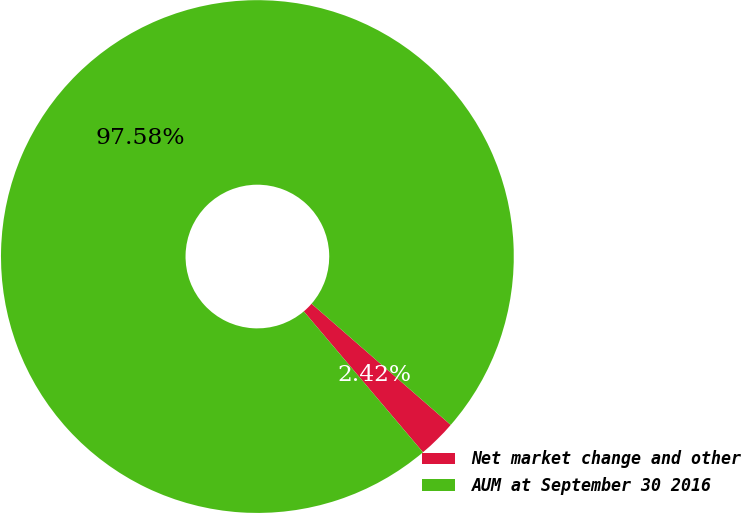<chart> <loc_0><loc_0><loc_500><loc_500><pie_chart><fcel>Net market change and other<fcel>AUM at September 30 2016<nl><fcel>2.42%<fcel>97.58%<nl></chart> 